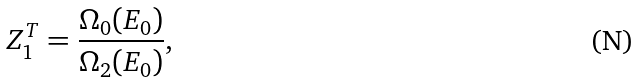<formula> <loc_0><loc_0><loc_500><loc_500>Z ^ { T } _ { 1 } = \frac { \Omega _ { 0 } ( E _ { 0 } ) } { \Omega _ { 2 } ( E _ { 0 } ) } ,</formula> 